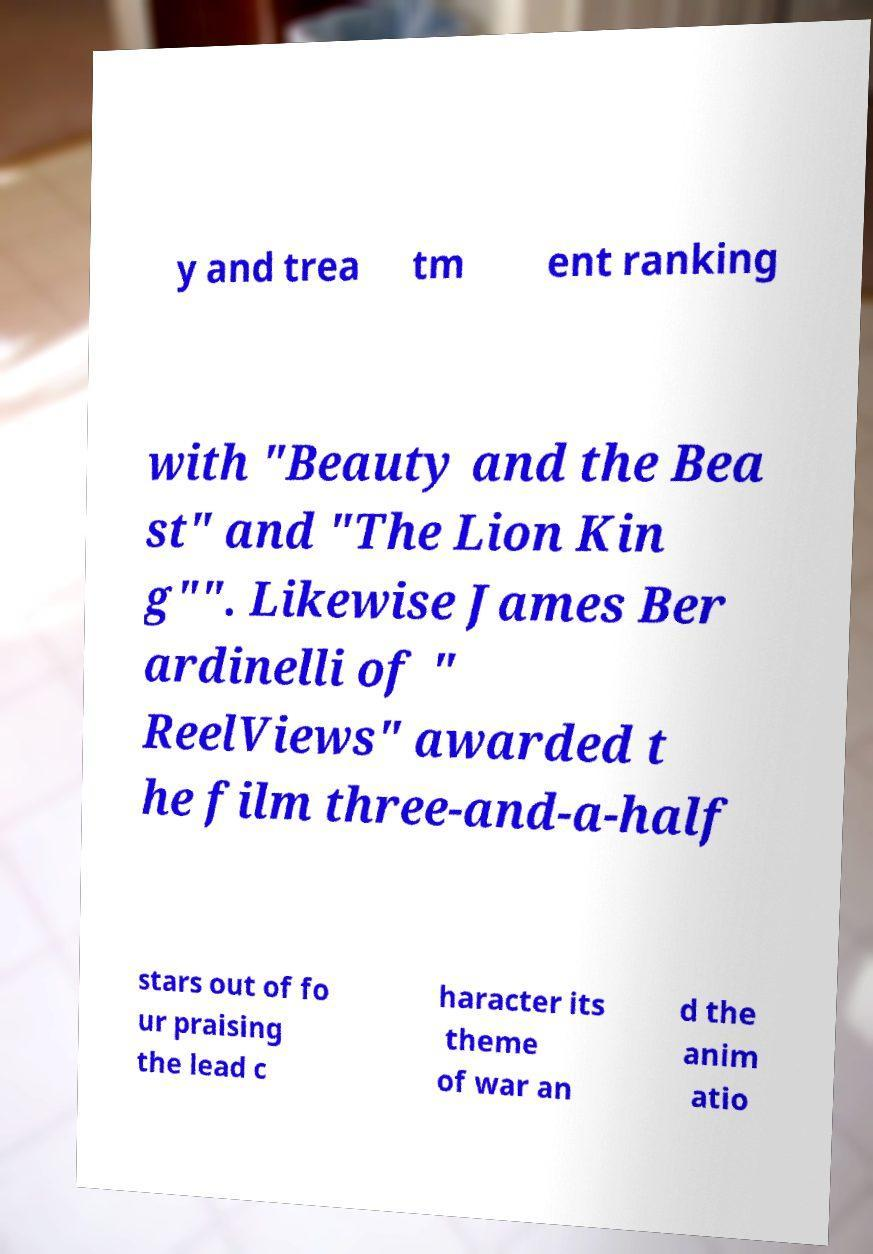Please read and relay the text visible in this image. What does it say? y and trea tm ent ranking with "Beauty and the Bea st" and "The Lion Kin g"". Likewise James Ber ardinelli of " ReelViews" awarded t he film three-and-a-half stars out of fo ur praising the lead c haracter its theme of war an d the anim atio 